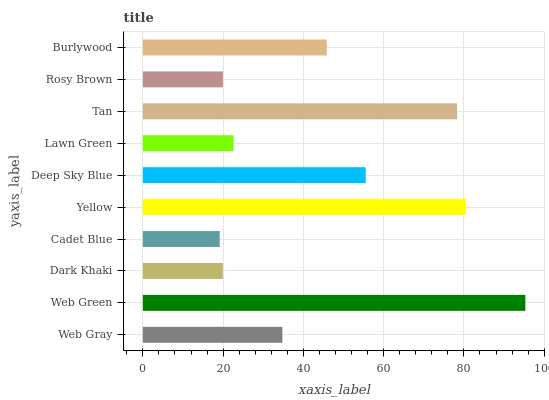Is Cadet Blue the minimum?
Answer yes or no. Yes. Is Web Green the maximum?
Answer yes or no. Yes. Is Dark Khaki the minimum?
Answer yes or no. No. Is Dark Khaki the maximum?
Answer yes or no. No. Is Web Green greater than Dark Khaki?
Answer yes or no. Yes. Is Dark Khaki less than Web Green?
Answer yes or no. Yes. Is Dark Khaki greater than Web Green?
Answer yes or no. No. Is Web Green less than Dark Khaki?
Answer yes or no. No. Is Burlywood the high median?
Answer yes or no. Yes. Is Web Gray the low median?
Answer yes or no. Yes. Is Rosy Brown the high median?
Answer yes or no. No. Is Yellow the low median?
Answer yes or no. No. 